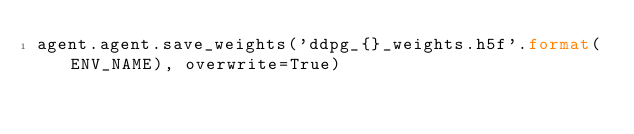<code> <loc_0><loc_0><loc_500><loc_500><_Python_>agent.agent.save_weights('ddpg_{}_weights.h5f'.format(ENV_NAME), overwrite=True)
</code> 